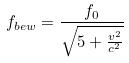<formula> <loc_0><loc_0><loc_500><loc_500>f _ { b e w } = \frac { f _ { 0 } } { \sqrt { 5 + \frac { v ^ { 2 } } { c ^ { 2 } } } }</formula> 